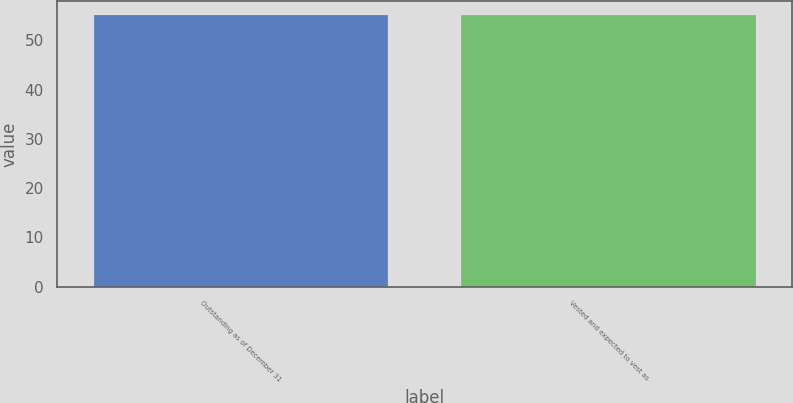Convert chart to OTSL. <chart><loc_0><loc_0><loc_500><loc_500><bar_chart><fcel>Outstanding as of December 31<fcel>Vested and expected to vest as<nl><fcel>55.2<fcel>55.19<nl></chart> 